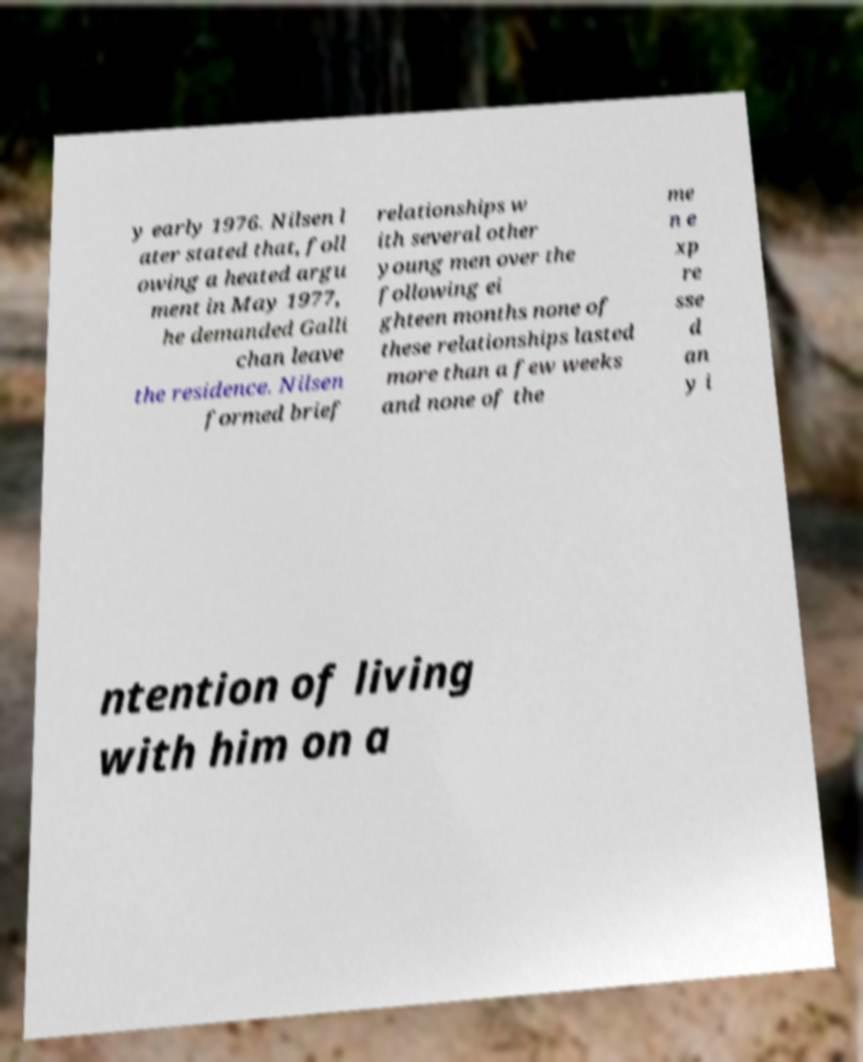Please identify and transcribe the text found in this image. y early 1976. Nilsen l ater stated that, foll owing a heated argu ment in May 1977, he demanded Galli chan leave the residence. Nilsen formed brief relationships w ith several other young men over the following ei ghteen months none of these relationships lasted more than a few weeks and none of the me n e xp re sse d an y i ntention of living with him on a 